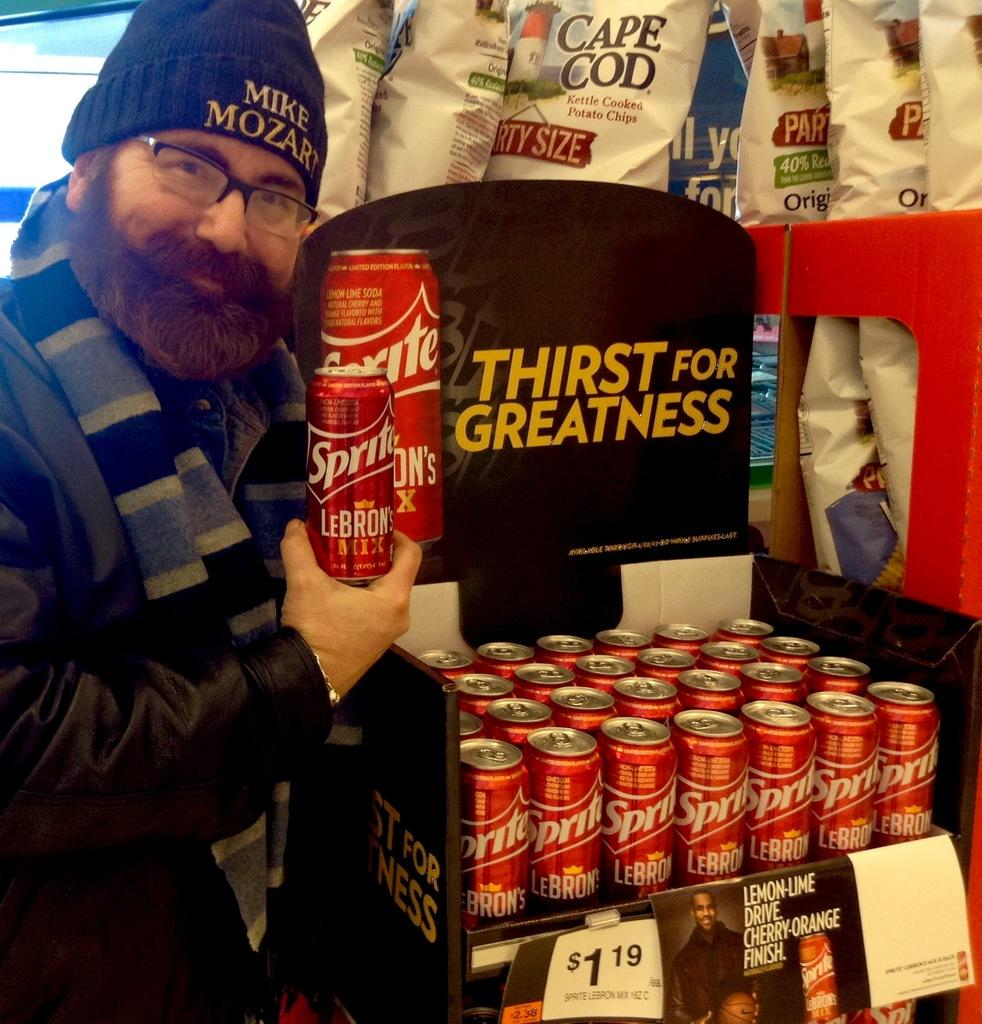Provide a one-sentence caption for the provided image. Multiple bottles of Sprite  arranged in a shelf near some potato chips. 